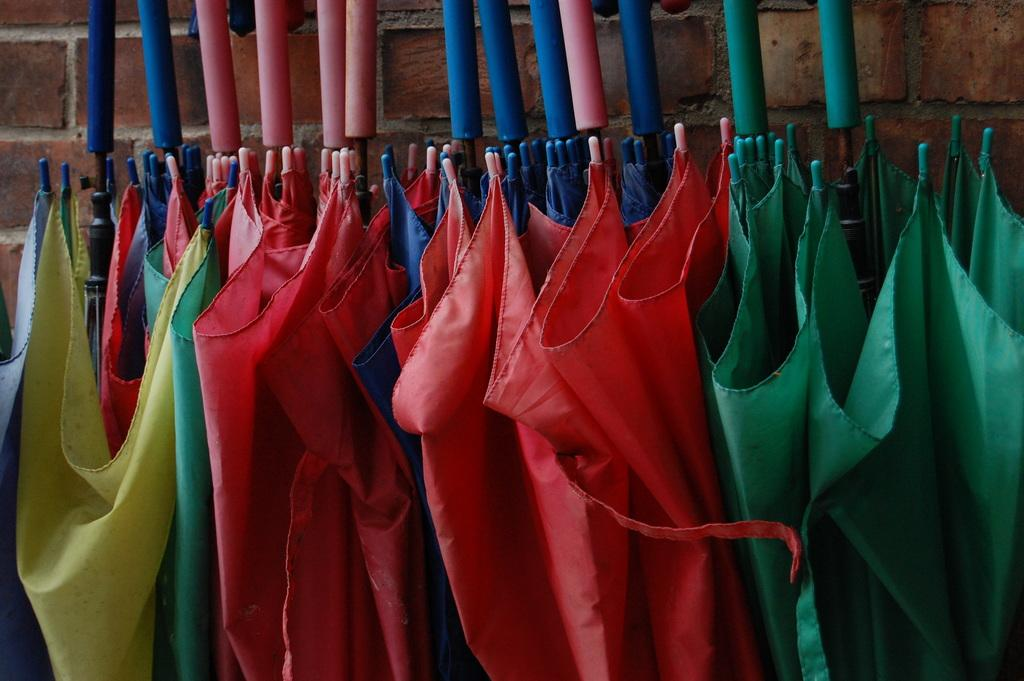What objects can be seen in the image? There are umbrellas in the image. Can you describe the umbrellas in more detail? The umbrellas are in different colors. What else is visible in the image besides the umbrellas? There is a brick wall visible in the image. Can you hear the sound of a whistle in the image? There is no whistle present in the image, so it is not possible to hear its sound. 